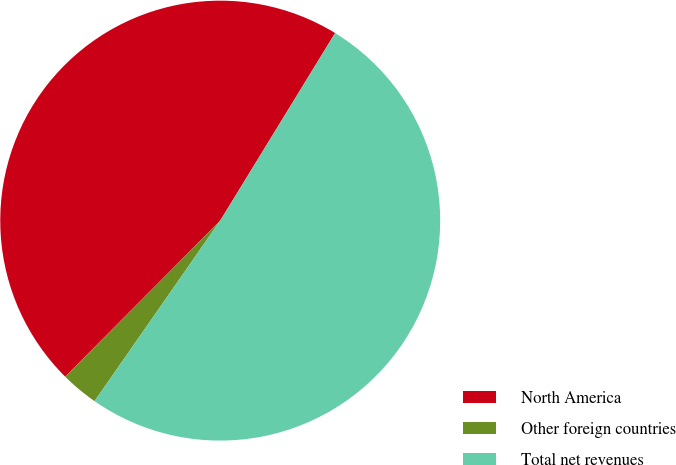Convert chart. <chart><loc_0><loc_0><loc_500><loc_500><pie_chart><fcel>North America<fcel>Other foreign countries<fcel>Total net revenues<nl><fcel>46.3%<fcel>2.77%<fcel>50.93%<nl></chart> 